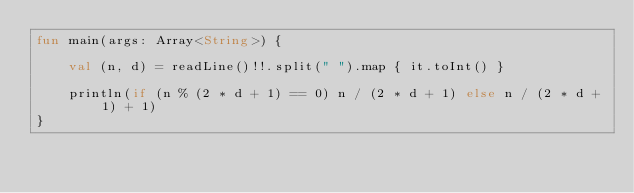<code> <loc_0><loc_0><loc_500><loc_500><_Kotlin_>fun main(args: Array<String>) {

    val (n, d) = readLine()!!.split(" ").map { it.toInt() }

    println(if (n % (2 * d + 1) == 0) n / (2 * d + 1) else n / (2 * d + 1) + 1)
}
</code> 